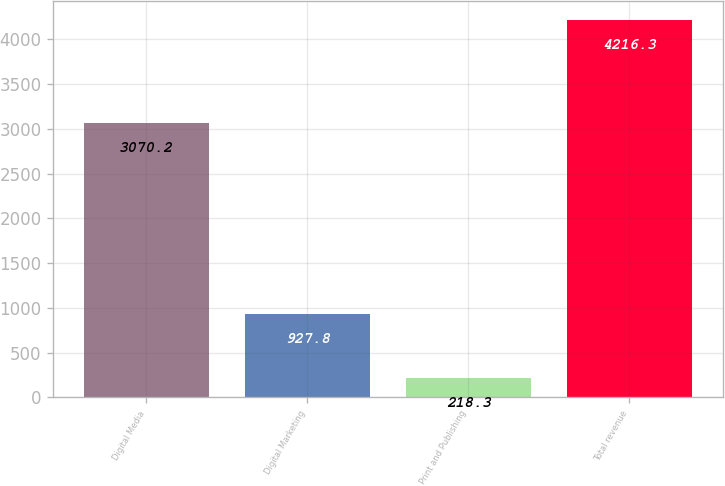<chart> <loc_0><loc_0><loc_500><loc_500><bar_chart><fcel>Digital Media<fcel>Digital Marketing<fcel>Print and Publishing<fcel>Total revenue<nl><fcel>3070.2<fcel>927.8<fcel>218.3<fcel>4216.3<nl></chart> 